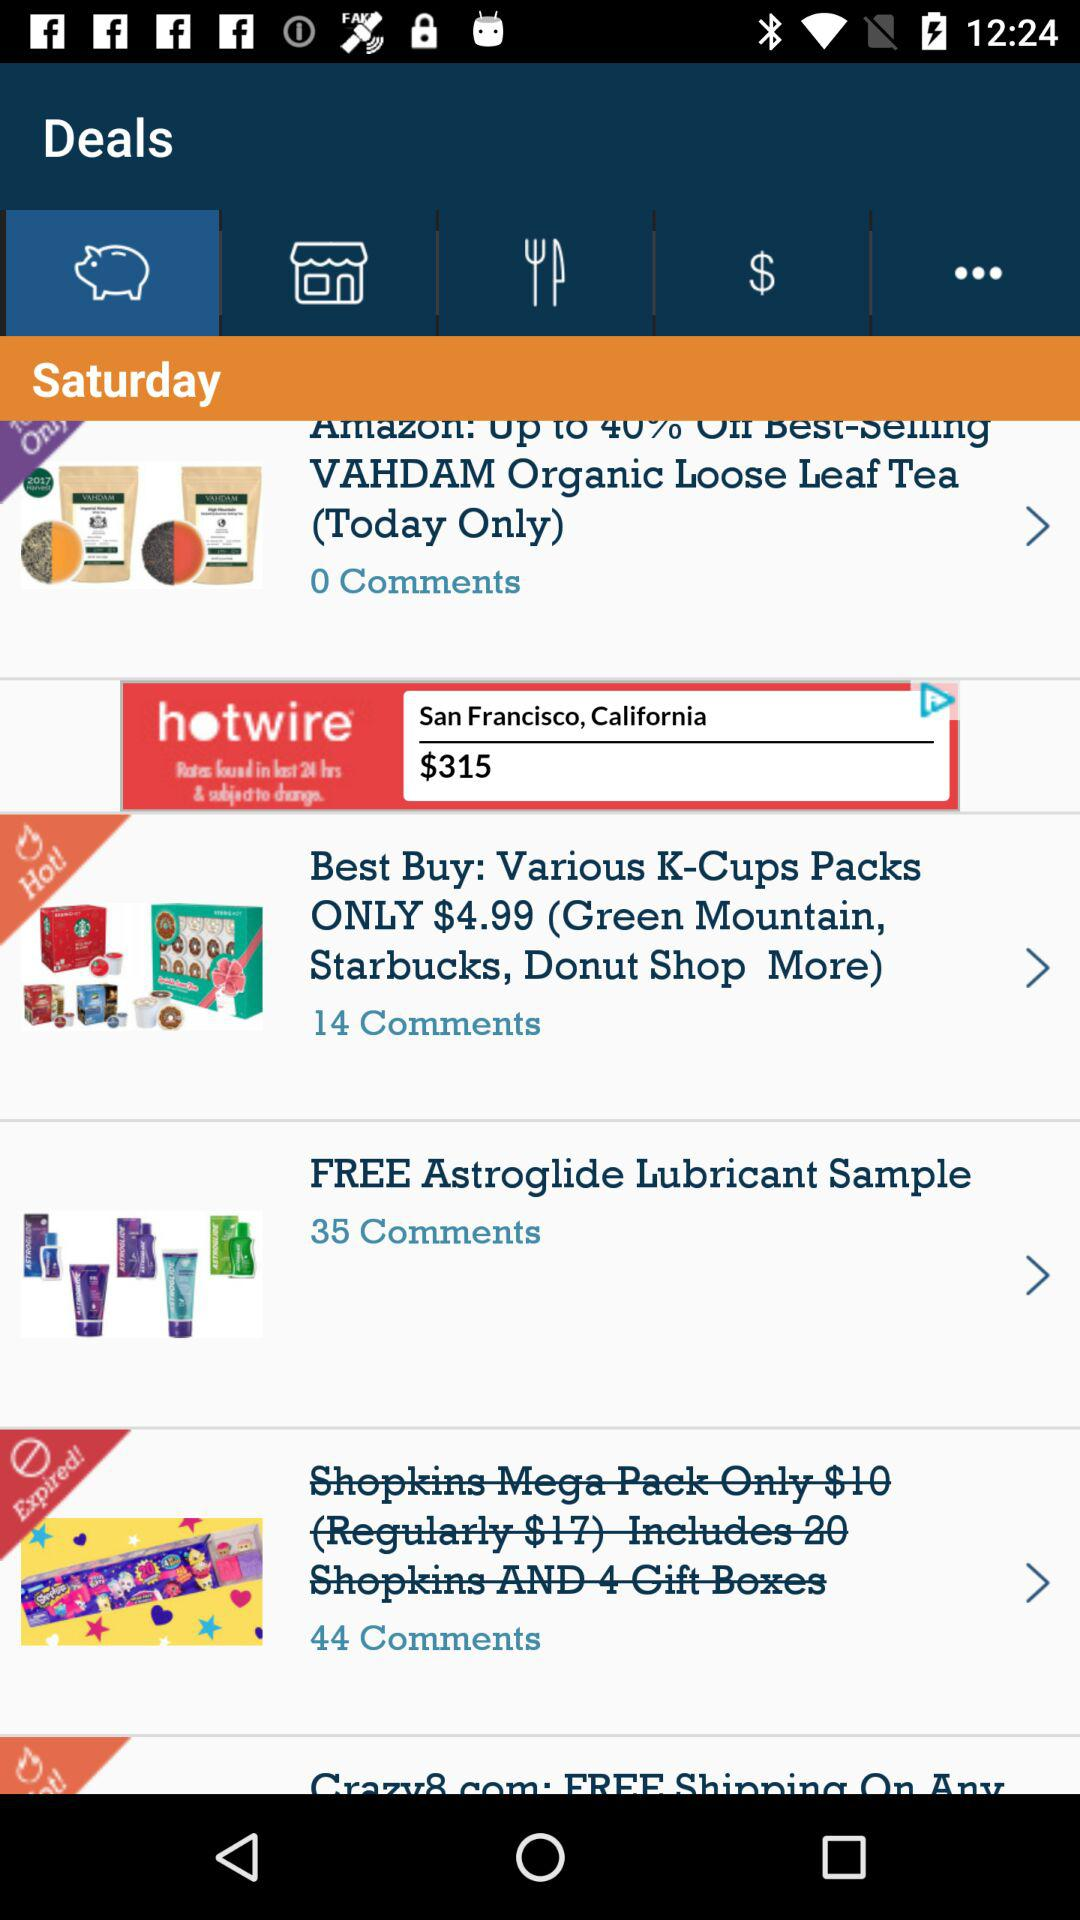How many comments are there on the "FREE Astroglide Lubricant Sample"? There are 35 comments on the "FREE Astroglide Lubricant Sample". 